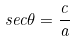<formula> <loc_0><loc_0><loc_500><loc_500>s e c \theta = \frac { c } { a }</formula> 